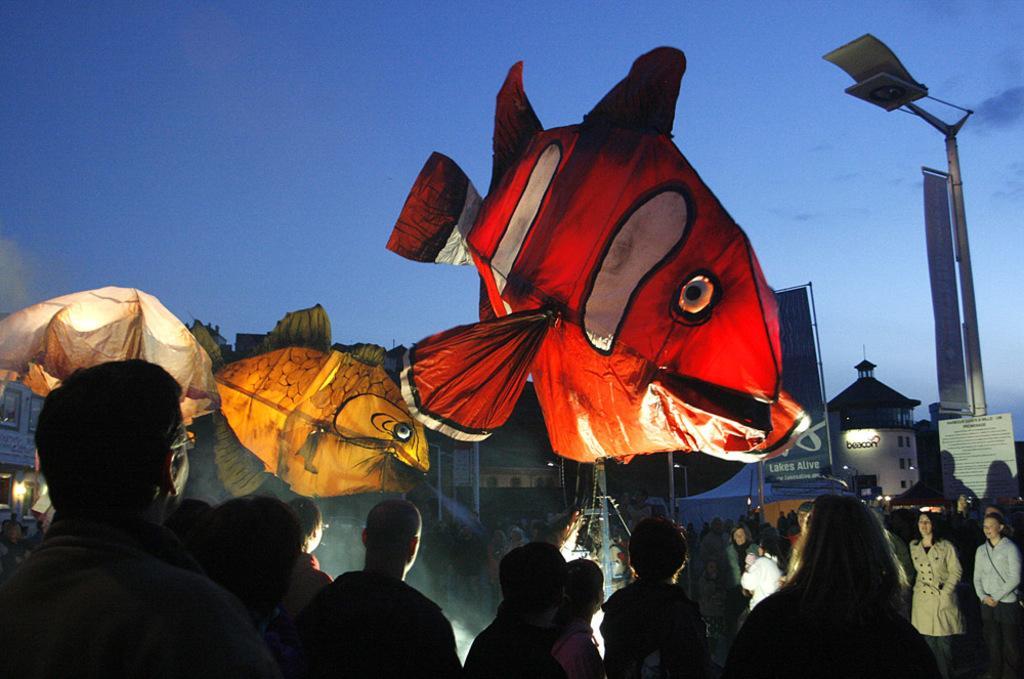Please provide a concise description of this image. In this image I can see people are standing. In the background I can see fish balloons, poles, a building and the sky. 